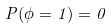Convert formula to latex. <formula><loc_0><loc_0><loc_500><loc_500>P ( \phi = 1 ) = 0</formula> 